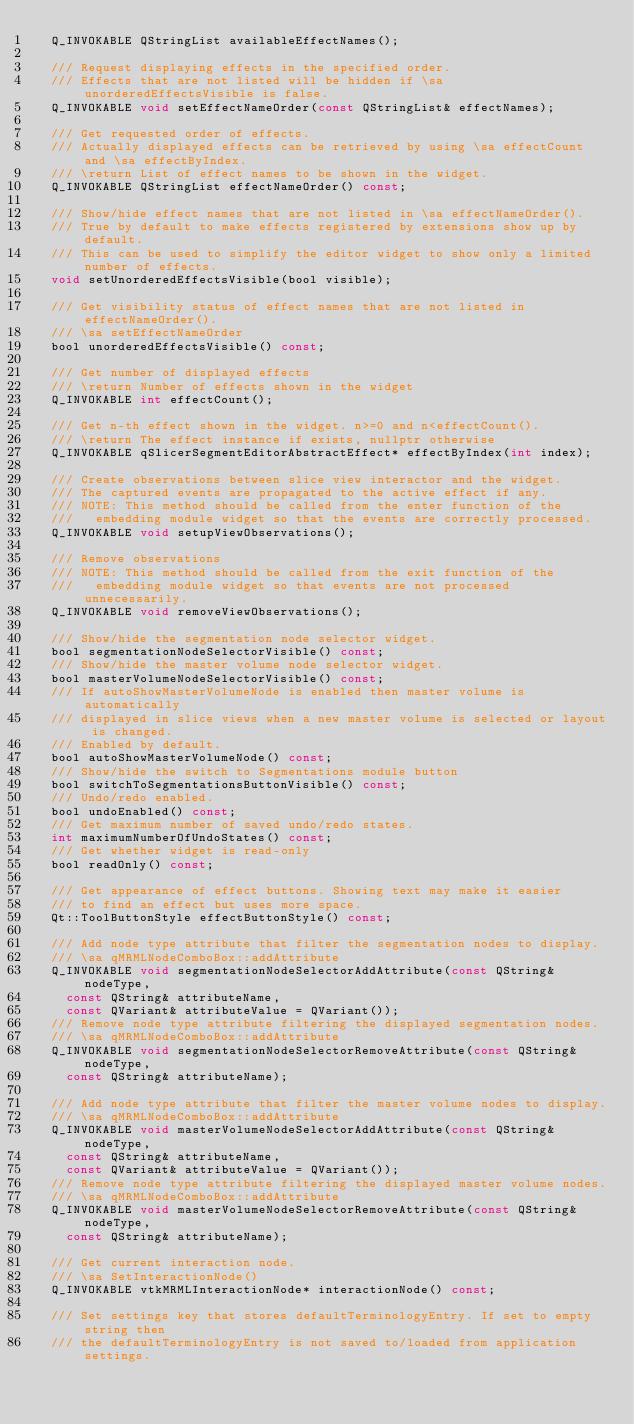<code> <loc_0><loc_0><loc_500><loc_500><_C_>  Q_INVOKABLE QStringList availableEffectNames();

  /// Request displaying effects in the specified order.
  /// Effects that are not listed will be hidden if \sa unorderedEffectsVisible is false.
  Q_INVOKABLE void setEffectNameOrder(const QStringList& effectNames);

  /// Get requested order of effects.
  /// Actually displayed effects can be retrieved by using \sa effectCount and \sa effectByIndex.
  /// \return List of effect names to be shown in the widget.
  Q_INVOKABLE QStringList effectNameOrder() const;

  /// Show/hide effect names that are not listed in \sa effectNameOrder().
  /// True by default to make effects registered by extensions show up by default.
  /// This can be used to simplify the editor widget to show only a limited number of effects.
  void setUnorderedEffectsVisible(bool visible);

  /// Get visibility status of effect names that are not listed in effectNameOrder().
  /// \sa setEffectNameOrder
  bool unorderedEffectsVisible() const;

  /// Get number of displayed effects
  /// \return Number of effects shown in the widget
  Q_INVOKABLE int effectCount();

  /// Get n-th effect shown in the widget. n>=0 and n<effectCount().
  /// \return The effect instance if exists, nullptr otherwise
  Q_INVOKABLE qSlicerSegmentEditorAbstractEffect* effectByIndex(int index);

  /// Create observations between slice view interactor and the widget.
  /// The captured events are propagated to the active effect if any.
  /// NOTE: This method should be called from the enter function of the
  ///   embedding module widget so that the events are correctly processed.
  Q_INVOKABLE void setupViewObservations();

  /// Remove observations
  /// NOTE: This method should be called from the exit function of the
  ///   embedding module widget so that events are not processed unnecessarily.
  Q_INVOKABLE void removeViewObservations();

  /// Show/hide the segmentation node selector widget.
  bool segmentationNodeSelectorVisible() const;
  /// Show/hide the master volume node selector widget.
  bool masterVolumeNodeSelectorVisible() const;
  /// If autoShowMasterVolumeNode is enabled then master volume is automatically
  /// displayed in slice views when a new master volume is selected or layout is changed.
  /// Enabled by default.
  bool autoShowMasterVolumeNode() const;
  /// Show/hide the switch to Segmentations module button
  bool switchToSegmentationsButtonVisible() const;
  /// Undo/redo enabled.
  bool undoEnabled() const;
  /// Get maximum number of saved undo/redo states.
  int maximumNumberOfUndoStates() const;
  /// Get whether widget is read-only
  bool readOnly() const;

  /// Get appearance of effect buttons. Showing text may make it easier
  /// to find an effect but uses more space.
  Qt::ToolButtonStyle effectButtonStyle() const;

  /// Add node type attribute that filter the segmentation nodes to display.
  /// \sa qMRMLNodeComboBox::addAttribute
  Q_INVOKABLE void segmentationNodeSelectorAddAttribute(const QString& nodeType,
    const QString& attributeName,
    const QVariant& attributeValue = QVariant());
  /// Remove node type attribute filtering the displayed segmentation nodes.
  /// \sa qMRMLNodeComboBox::addAttribute
  Q_INVOKABLE void segmentationNodeSelectorRemoveAttribute(const QString& nodeType,
    const QString& attributeName);

  /// Add node type attribute that filter the master volume nodes to display.
  /// \sa qMRMLNodeComboBox::addAttribute
  Q_INVOKABLE void masterVolumeNodeSelectorAddAttribute(const QString& nodeType,
    const QString& attributeName,
    const QVariant& attributeValue = QVariant());
  /// Remove node type attribute filtering the displayed master volume nodes.
  /// \sa qMRMLNodeComboBox::addAttribute
  Q_INVOKABLE void masterVolumeNodeSelectorRemoveAttribute(const QString& nodeType,
    const QString& attributeName);

  /// Get current interaction node.
  /// \sa SetInteractionNode()
  Q_INVOKABLE vtkMRMLInteractionNode* interactionNode() const;

  /// Set settings key that stores defaultTerminologyEntry. If set to empty string then
  /// the defaultTerminologyEntry is not saved to/loaded from application settings.</code> 